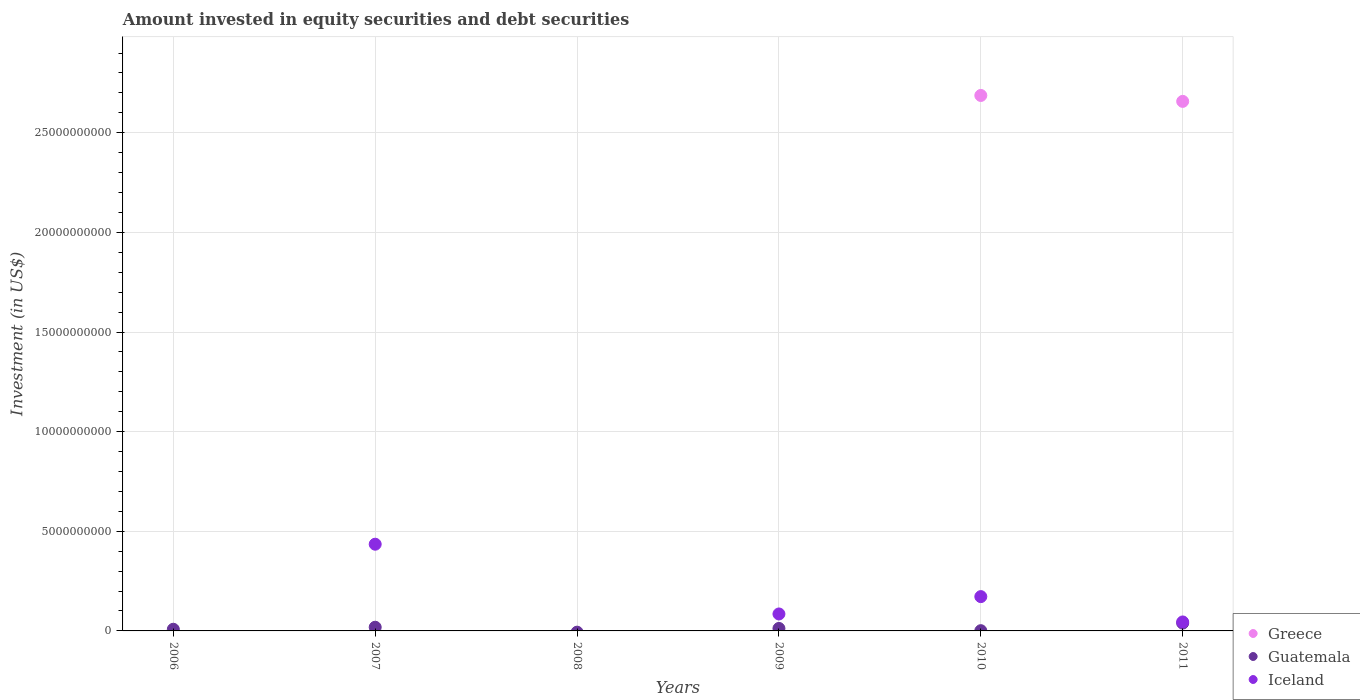How many different coloured dotlines are there?
Offer a terse response. 3. What is the amount invested in equity securities and debt securities in Iceland in 2010?
Provide a short and direct response. 1.72e+09. Across all years, what is the maximum amount invested in equity securities and debt securities in Greece?
Give a very brief answer. 2.69e+1. Across all years, what is the minimum amount invested in equity securities and debt securities in Greece?
Give a very brief answer. 0. What is the total amount invested in equity securities and debt securities in Guatemala in the graph?
Provide a succinct answer. 7.97e+08. What is the difference between the amount invested in equity securities and debt securities in Iceland in 2009 and that in 2010?
Offer a very short reply. -8.70e+08. What is the difference between the amount invested in equity securities and debt securities in Iceland in 2007 and the amount invested in equity securities and debt securities in Greece in 2008?
Ensure brevity in your answer.  4.35e+09. What is the average amount invested in equity securities and debt securities in Greece per year?
Give a very brief answer. 8.91e+09. In the year 2007, what is the difference between the amount invested in equity securities and debt securities in Guatemala and amount invested in equity securities and debt securities in Iceland?
Make the answer very short. -4.17e+09. What is the ratio of the amount invested in equity securities and debt securities in Guatemala in 2007 to that in 2010?
Provide a succinct answer. 15.57. Is the amount invested in equity securities and debt securities in Greece in 2010 less than that in 2011?
Make the answer very short. No. Is the difference between the amount invested in equity securities and debt securities in Guatemala in 2007 and 2011 greater than the difference between the amount invested in equity securities and debt securities in Iceland in 2007 and 2011?
Give a very brief answer. No. What is the difference between the highest and the second highest amount invested in equity securities and debt securities in Guatemala?
Provide a short and direct response. 2.07e+08. What is the difference between the highest and the lowest amount invested in equity securities and debt securities in Guatemala?
Your answer should be compact. 3.92e+08. In how many years, is the amount invested in equity securities and debt securities in Guatemala greater than the average amount invested in equity securities and debt securities in Guatemala taken over all years?
Your response must be concise. 2. Is it the case that in every year, the sum of the amount invested in equity securities and debt securities in Guatemala and amount invested in equity securities and debt securities in Greece  is greater than the amount invested in equity securities and debt securities in Iceland?
Provide a short and direct response. No. Does the amount invested in equity securities and debt securities in Greece monotonically increase over the years?
Give a very brief answer. No. Is the amount invested in equity securities and debt securities in Iceland strictly greater than the amount invested in equity securities and debt securities in Guatemala over the years?
Offer a terse response. No. How many dotlines are there?
Keep it short and to the point. 3. How many years are there in the graph?
Your answer should be very brief. 6. Does the graph contain any zero values?
Keep it short and to the point. Yes. How many legend labels are there?
Offer a very short reply. 3. What is the title of the graph?
Offer a terse response. Amount invested in equity securities and debt securities. Does "Haiti" appear as one of the legend labels in the graph?
Your answer should be very brief. No. What is the label or title of the X-axis?
Offer a very short reply. Years. What is the label or title of the Y-axis?
Your answer should be compact. Investment (in US$). What is the Investment (in US$) in Greece in 2006?
Ensure brevity in your answer.  0. What is the Investment (in US$) of Guatemala in 2006?
Your response must be concise. 8.34e+07. What is the Investment (in US$) of Guatemala in 2007?
Provide a succinct answer. 1.85e+08. What is the Investment (in US$) in Iceland in 2007?
Your response must be concise. 4.35e+09. What is the Investment (in US$) of Greece in 2009?
Your answer should be compact. 0. What is the Investment (in US$) of Guatemala in 2009?
Your answer should be compact. 1.25e+08. What is the Investment (in US$) in Iceland in 2009?
Give a very brief answer. 8.51e+08. What is the Investment (in US$) in Greece in 2010?
Your answer should be very brief. 2.69e+1. What is the Investment (in US$) of Guatemala in 2010?
Your answer should be very brief. 1.19e+07. What is the Investment (in US$) in Iceland in 2010?
Provide a succinct answer. 1.72e+09. What is the Investment (in US$) of Greece in 2011?
Your response must be concise. 2.66e+1. What is the Investment (in US$) in Guatemala in 2011?
Keep it short and to the point. 3.92e+08. What is the Investment (in US$) in Iceland in 2011?
Provide a succinct answer. 4.51e+08. Across all years, what is the maximum Investment (in US$) of Greece?
Your answer should be compact. 2.69e+1. Across all years, what is the maximum Investment (in US$) in Guatemala?
Offer a terse response. 3.92e+08. Across all years, what is the maximum Investment (in US$) in Iceland?
Keep it short and to the point. 4.35e+09. Across all years, what is the minimum Investment (in US$) of Greece?
Make the answer very short. 0. Across all years, what is the minimum Investment (in US$) in Iceland?
Make the answer very short. 0. What is the total Investment (in US$) of Greece in the graph?
Provide a succinct answer. 5.34e+1. What is the total Investment (in US$) in Guatemala in the graph?
Make the answer very short. 7.97e+08. What is the total Investment (in US$) in Iceland in the graph?
Offer a terse response. 7.38e+09. What is the difference between the Investment (in US$) in Guatemala in 2006 and that in 2007?
Offer a very short reply. -1.02e+08. What is the difference between the Investment (in US$) of Guatemala in 2006 and that in 2009?
Keep it short and to the point. -4.12e+07. What is the difference between the Investment (in US$) in Guatemala in 2006 and that in 2010?
Make the answer very short. 7.15e+07. What is the difference between the Investment (in US$) in Guatemala in 2006 and that in 2011?
Offer a terse response. -3.09e+08. What is the difference between the Investment (in US$) of Guatemala in 2007 and that in 2009?
Offer a very short reply. 6.03e+07. What is the difference between the Investment (in US$) of Iceland in 2007 and that in 2009?
Offer a terse response. 3.50e+09. What is the difference between the Investment (in US$) of Guatemala in 2007 and that in 2010?
Give a very brief answer. 1.73e+08. What is the difference between the Investment (in US$) in Iceland in 2007 and that in 2010?
Offer a very short reply. 2.63e+09. What is the difference between the Investment (in US$) in Guatemala in 2007 and that in 2011?
Your answer should be very brief. -2.07e+08. What is the difference between the Investment (in US$) of Iceland in 2007 and that in 2011?
Ensure brevity in your answer.  3.90e+09. What is the difference between the Investment (in US$) of Guatemala in 2009 and that in 2010?
Provide a succinct answer. 1.13e+08. What is the difference between the Investment (in US$) in Iceland in 2009 and that in 2010?
Offer a very short reply. -8.70e+08. What is the difference between the Investment (in US$) of Guatemala in 2009 and that in 2011?
Your answer should be compact. -2.67e+08. What is the difference between the Investment (in US$) of Iceland in 2009 and that in 2011?
Provide a succinct answer. 4.01e+08. What is the difference between the Investment (in US$) in Greece in 2010 and that in 2011?
Ensure brevity in your answer.  2.97e+08. What is the difference between the Investment (in US$) in Guatemala in 2010 and that in 2011?
Keep it short and to the point. -3.80e+08. What is the difference between the Investment (in US$) in Iceland in 2010 and that in 2011?
Offer a terse response. 1.27e+09. What is the difference between the Investment (in US$) in Guatemala in 2006 and the Investment (in US$) in Iceland in 2007?
Offer a very short reply. -4.27e+09. What is the difference between the Investment (in US$) in Guatemala in 2006 and the Investment (in US$) in Iceland in 2009?
Provide a short and direct response. -7.68e+08. What is the difference between the Investment (in US$) of Guatemala in 2006 and the Investment (in US$) of Iceland in 2010?
Ensure brevity in your answer.  -1.64e+09. What is the difference between the Investment (in US$) of Guatemala in 2006 and the Investment (in US$) of Iceland in 2011?
Give a very brief answer. -3.67e+08. What is the difference between the Investment (in US$) in Guatemala in 2007 and the Investment (in US$) in Iceland in 2009?
Offer a very short reply. -6.66e+08. What is the difference between the Investment (in US$) of Guatemala in 2007 and the Investment (in US$) of Iceland in 2010?
Your answer should be compact. -1.54e+09. What is the difference between the Investment (in US$) of Guatemala in 2007 and the Investment (in US$) of Iceland in 2011?
Ensure brevity in your answer.  -2.66e+08. What is the difference between the Investment (in US$) of Guatemala in 2009 and the Investment (in US$) of Iceland in 2010?
Give a very brief answer. -1.60e+09. What is the difference between the Investment (in US$) of Guatemala in 2009 and the Investment (in US$) of Iceland in 2011?
Make the answer very short. -3.26e+08. What is the difference between the Investment (in US$) in Greece in 2010 and the Investment (in US$) in Guatemala in 2011?
Offer a very short reply. 2.65e+1. What is the difference between the Investment (in US$) in Greece in 2010 and the Investment (in US$) in Iceland in 2011?
Provide a succinct answer. 2.64e+1. What is the difference between the Investment (in US$) of Guatemala in 2010 and the Investment (in US$) of Iceland in 2011?
Make the answer very short. -4.39e+08. What is the average Investment (in US$) in Greece per year?
Make the answer very short. 8.91e+09. What is the average Investment (in US$) in Guatemala per year?
Your response must be concise. 1.33e+08. What is the average Investment (in US$) in Iceland per year?
Provide a succinct answer. 1.23e+09. In the year 2007, what is the difference between the Investment (in US$) in Guatemala and Investment (in US$) in Iceland?
Ensure brevity in your answer.  -4.17e+09. In the year 2009, what is the difference between the Investment (in US$) in Guatemala and Investment (in US$) in Iceland?
Keep it short and to the point. -7.27e+08. In the year 2010, what is the difference between the Investment (in US$) in Greece and Investment (in US$) in Guatemala?
Keep it short and to the point. 2.69e+1. In the year 2010, what is the difference between the Investment (in US$) in Greece and Investment (in US$) in Iceland?
Keep it short and to the point. 2.51e+1. In the year 2010, what is the difference between the Investment (in US$) in Guatemala and Investment (in US$) in Iceland?
Provide a short and direct response. -1.71e+09. In the year 2011, what is the difference between the Investment (in US$) in Greece and Investment (in US$) in Guatemala?
Offer a very short reply. 2.62e+1. In the year 2011, what is the difference between the Investment (in US$) of Greece and Investment (in US$) of Iceland?
Your response must be concise. 2.61e+1. In the year 2011, what is the difference between the Investment (in US$) of Guatemala and Investment (in US$) of Iceland?
Provide a succinct answer. -5.87e+07. What is the ratio of the Investment (in US$) of Guatemala in 2006 to that in 2007?
Provide a succinct answer. 0.45. What is the ratio of the Investment (in US$) of Guatemala in 2006 to that in 2009?
Your answer should be very brief. 0.67. What is the ratio of the Investment (in US$) of Guatemala in 2006 to that in 2010?
Ensure brevity in your answer.  7.02. What is the ratio of the Investment (in US$) of Guatemala in 2006 to that in 2011?
Your answer should be compact. 0.21. What is the ratio of the Investment (in US$) in Guatemala in 2007 to that in 2009?
Ensure brevity in your answer.  1.48. What is the ratio of the Investment (in US$) in Iceland in 2007 to that in 2009?
Your answer should be compact. 5.11. What is the ratio of the Investment (in US$) in Guatemala in 2007 to that in 2010?
Your answer should be compact. 15.57. What is the ratio of the Investment (in US$) in Iceland in 2007 to that in 2010?
Make the answer very short. 2.53. What is the ratio of the Investment (in US$) in Guatemala in 2007 to that in 2011?
Provide a succinct answer. 0.47. What is the ratio of the Investment (in US$) of Iceland in 2007 to that in 2011?
Give a very brief answer. 9.65. What is the ratio of the Investment (in US$) of Guatemala in 2009 to that in 2010?
Your answer should be very brief. 10.49. What is the ratio of the Investment (in US$) of Iceland in 2009 to that in 2010?
Keep it short and to the point. 0.49. What is the ratio of the Investment (in US$) in Guatemala in 2009 to that in 2011?
Give a very brief answer. 0.32. What is the ratio of the Investment (in US$) of Iceland in 2009 to that in 2011?
Your answer should be very brief. 1.89. What is the ratio of the Investment (in US$) of Greece in 2010 to that in 2011?
Offer a terse response. 1.01. What is the ratio of the Investment (in US$) in Guatemala in 2010 to that in 2011?
Keep it short and to the point. 0.03. What is the ratio of the Investment (in US$) of Iceland in 2010 to that in 2011?
Keep it short and to the point. 3.82. What is the difference between the highest and the second highest Investment (in US$) in Guatemala?
Ensure brevity in your answer.  2.07e+08. What is the difference between the highest and the second highest Investment (in US$) in Iceland?
Give a very brief answer. 2.63e+09. What is the difference between the highest and the lowest Investment (in US$) of Greece?
Give a very brief answer. 2.69e+1. What is the difference between the highest and the lowest Investment (in US$) of Guatemala?
Keep it short and to the point. 3.92e+08. What is the difference between the highest and the lowest Investment (in US$) of Iceland?
Provide a short and direct response. 4.35e+09. 